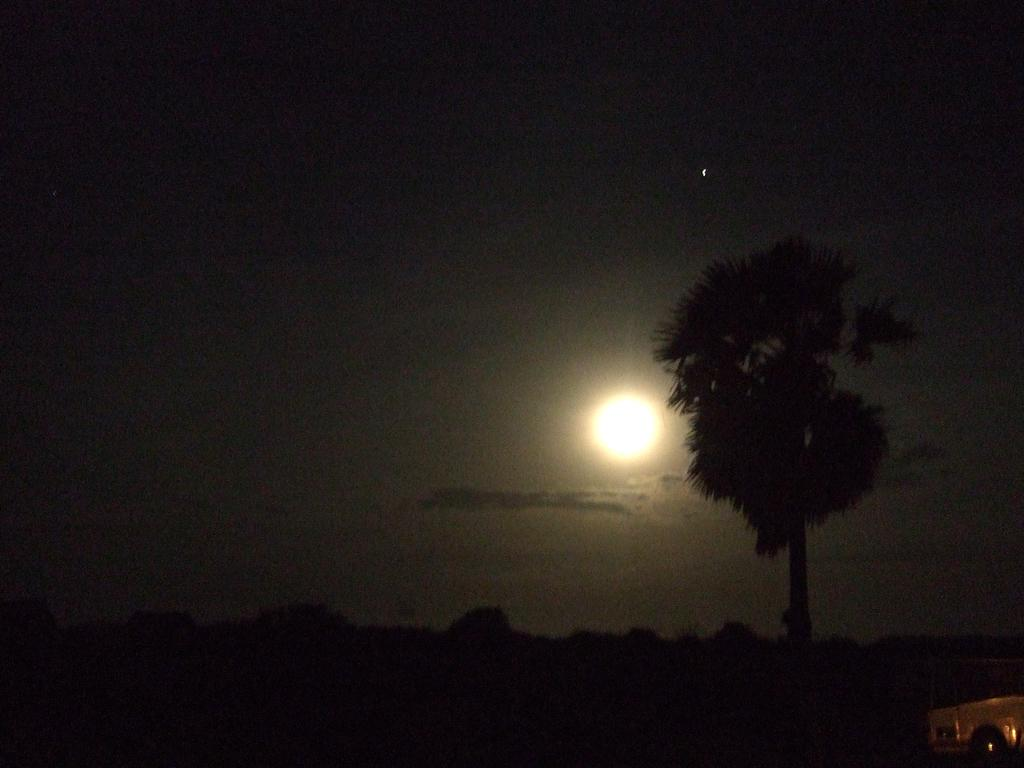What time of day was the image taken? The image was taken at night. What natural element can be seen in the image? There is a tree in the image. What part of the sky is visible in the image? The sky is visible in the image. What celestial body is visible in the sky? The moon is visible in the image. What is present on the path in the image? There is an item on the path in the image. What type of quartz can be seen on the tree in the image? There is no quartz present in the image, and the tree is not mentioned to have any quartz on it. How many legs are visible in the image? There are no legs visible in the image, as it does not feature any living beings with legs. 